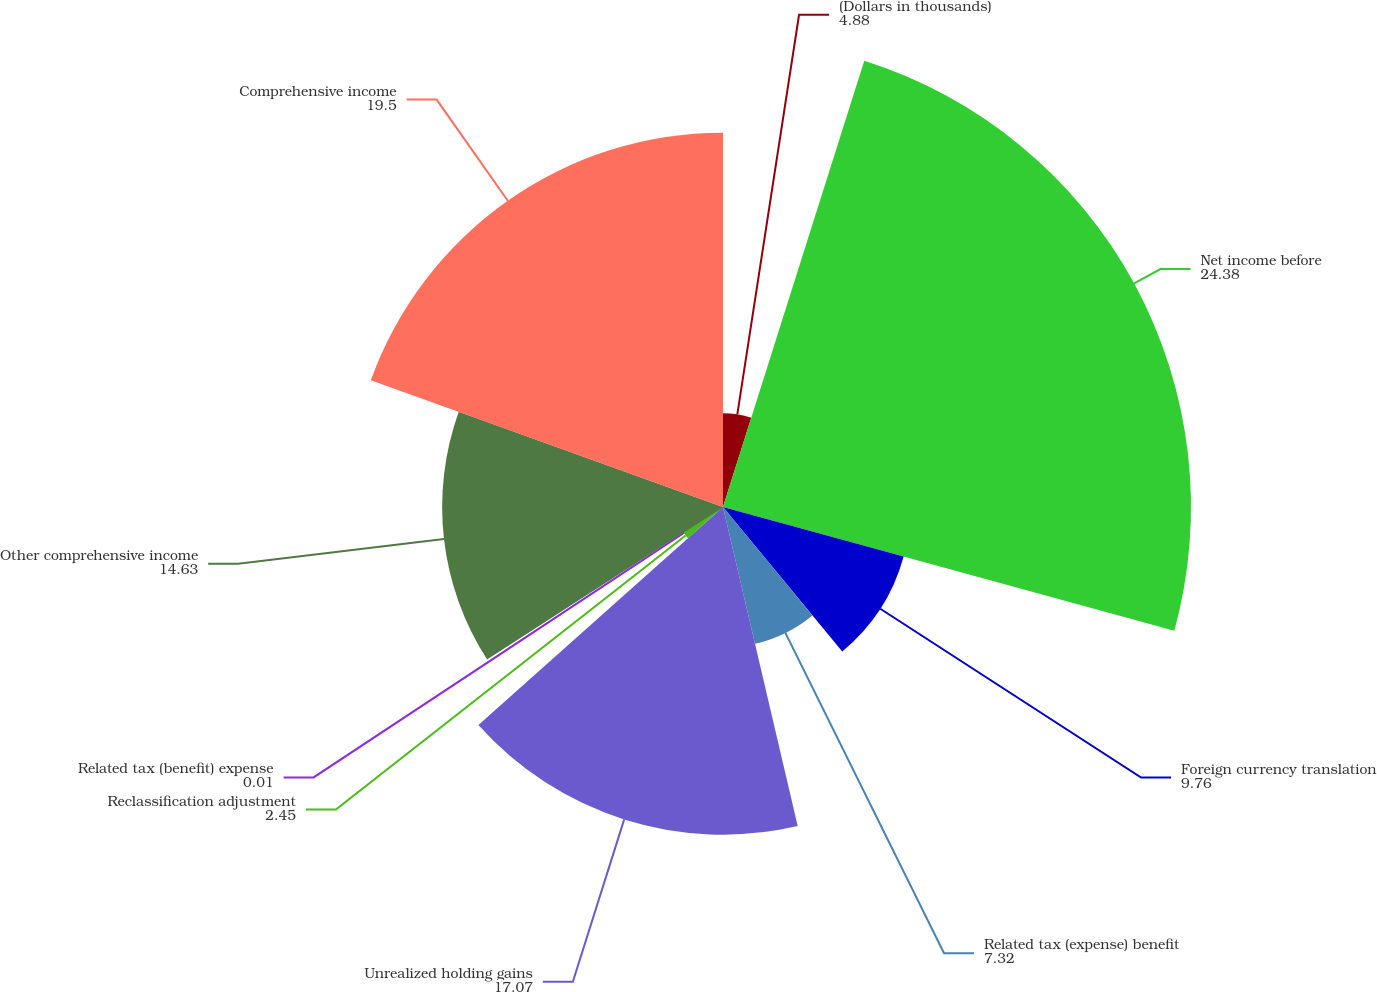Convert chart to OTSL. <chart><loc_0><loc_0><loc_500><loc_500><pie_chart><fcel>(Dollars in thousands)<fcel>Net income before<fcel>Foreign currency translation<fcel>Related tax (expense) benefit<fcel>Unrealized holding gains<fcel>Reclassification adjustment<fcel>Related tax (benefit) expense<fcel>Other comprehensive income<fcel>Comprehensive income<nl><fcel>4.88%<fcel>24.38%<fcel>9.76%<fcel>7.32%<fcel>17.07%<fcel>2.45%<fcel>0.01%<fcel>14.63%<fcel>19.5%<nl></chart> 